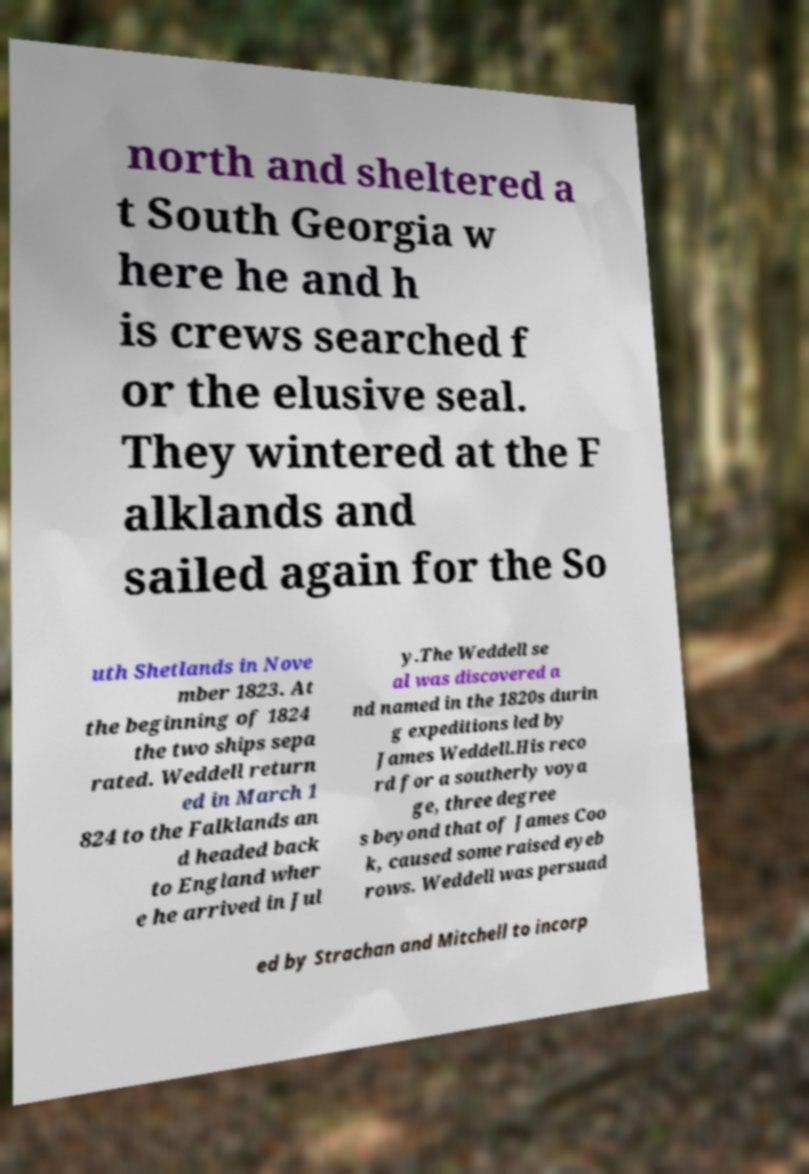Please identify and transcribe the text found in this image. north and sheltered a t South Georgia w here he and h is crews searched f or the elusive seal. They wintered at the F alklands and sailed again for the So uth Shetlands in Nove mber 1823. At the beginning of 1824 the two ships sepa rated. Weddell return ed in March 1 824 to the Falklands an d headed back to England wher e he arrived in Jul y.The Weddell se al was discovered a nd named in the 1820s durin g expeditions led by James Weddell.His reco rd for a southerly voya ge, three degree s beyond that of James Coo k, caused some raised eyeb rows. Weddell was persuad ed by Strachan and Mitchell to incorp 